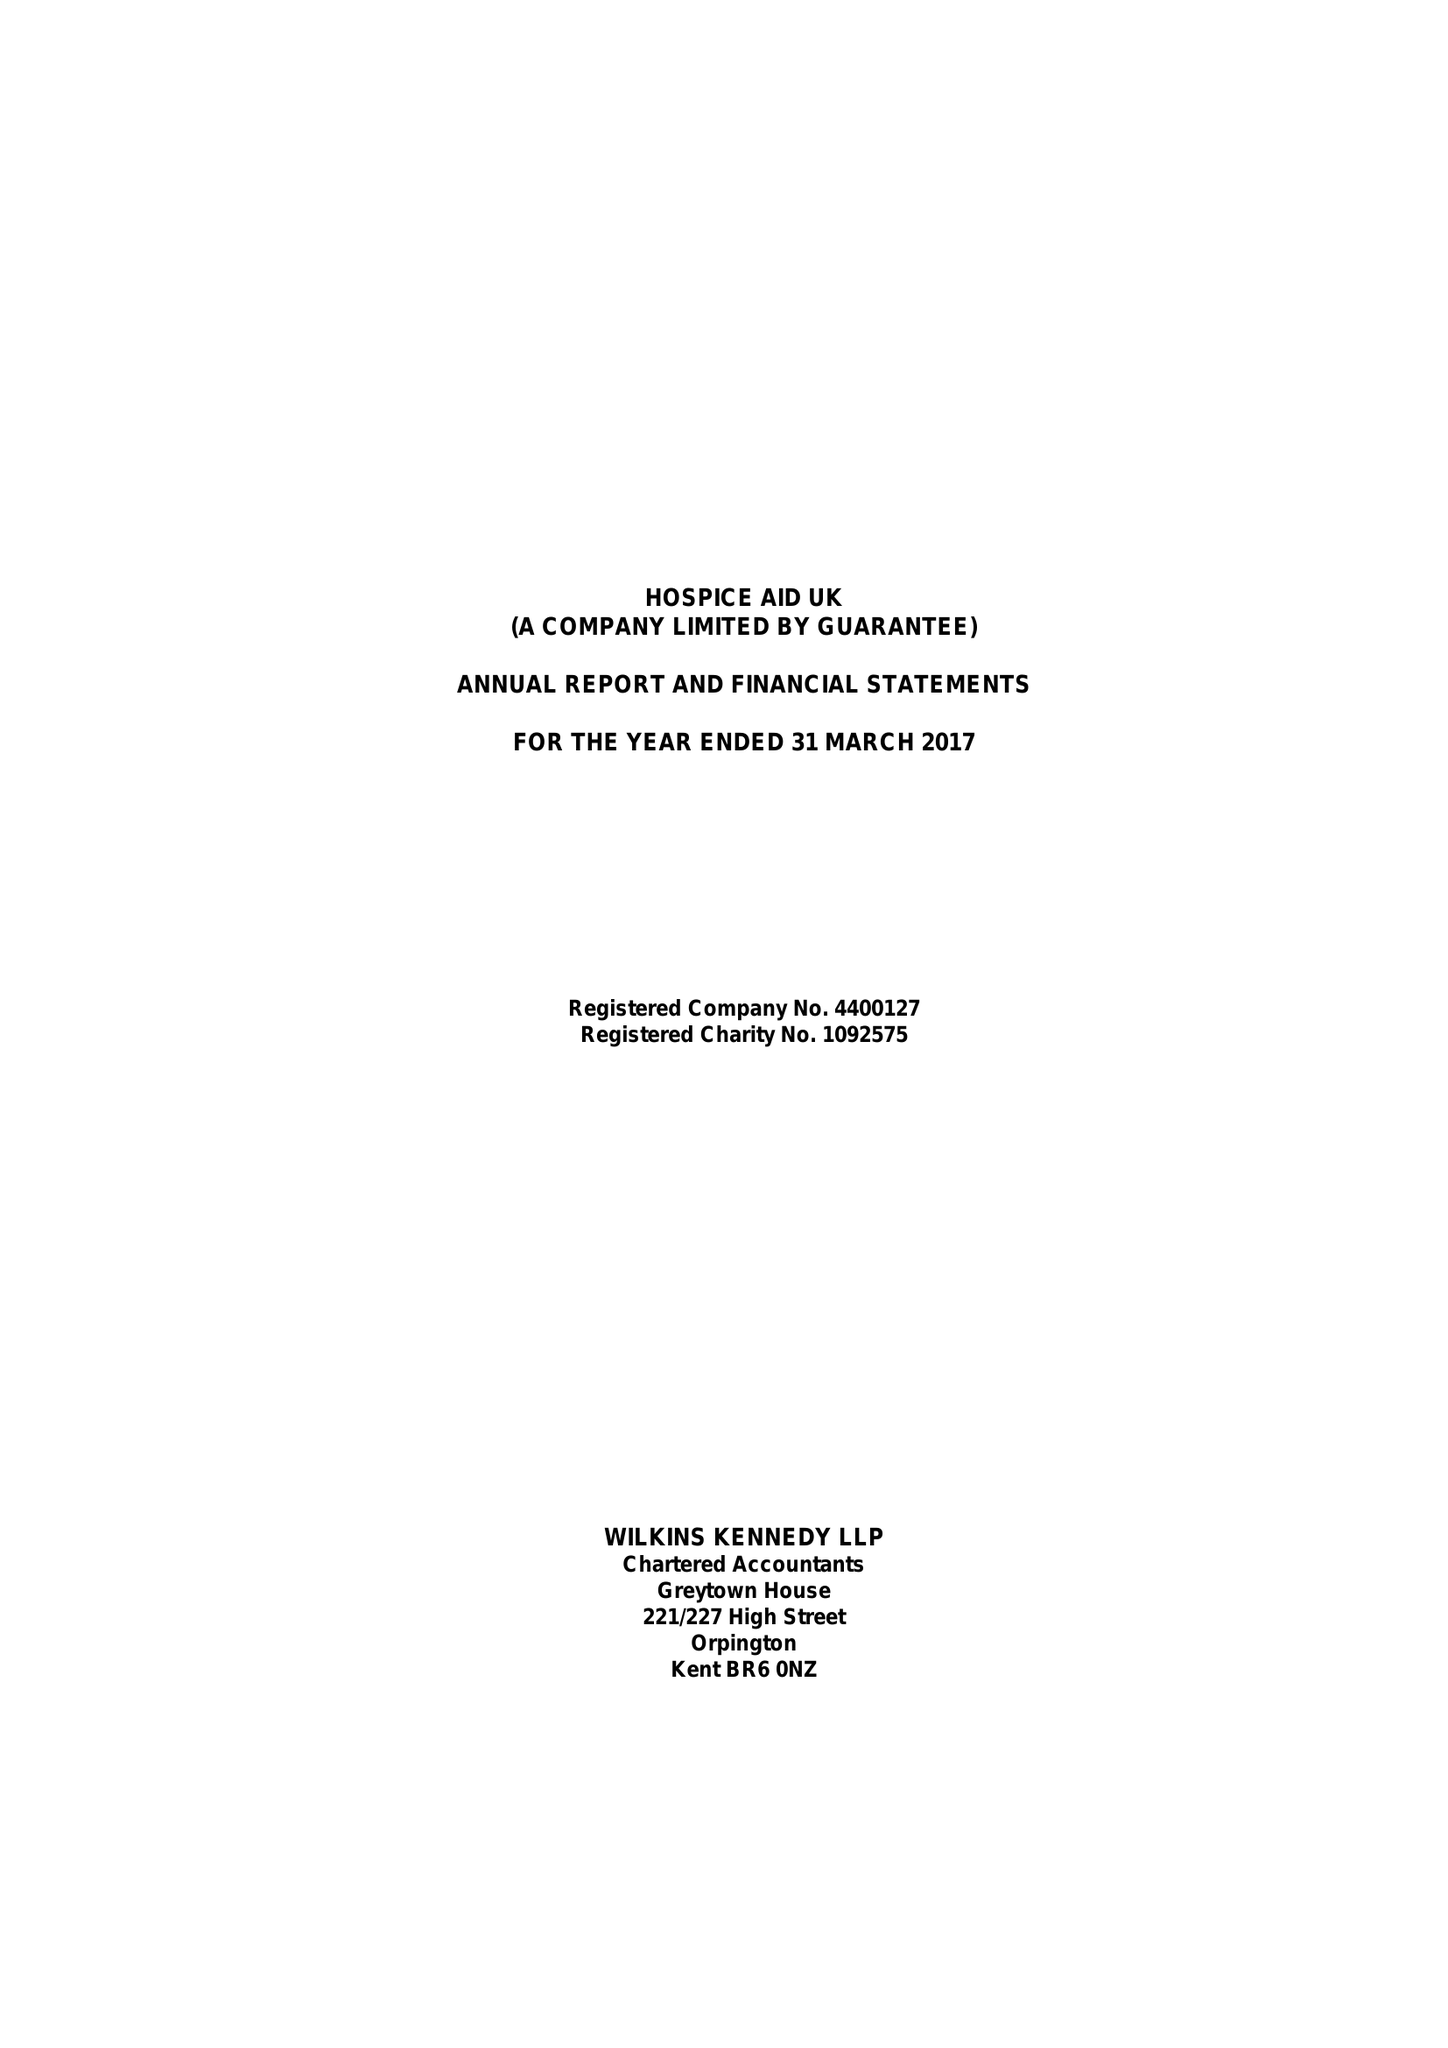What is the value for the address__postcode?
Answer the question using a single word or phrase. RH10 1HT 